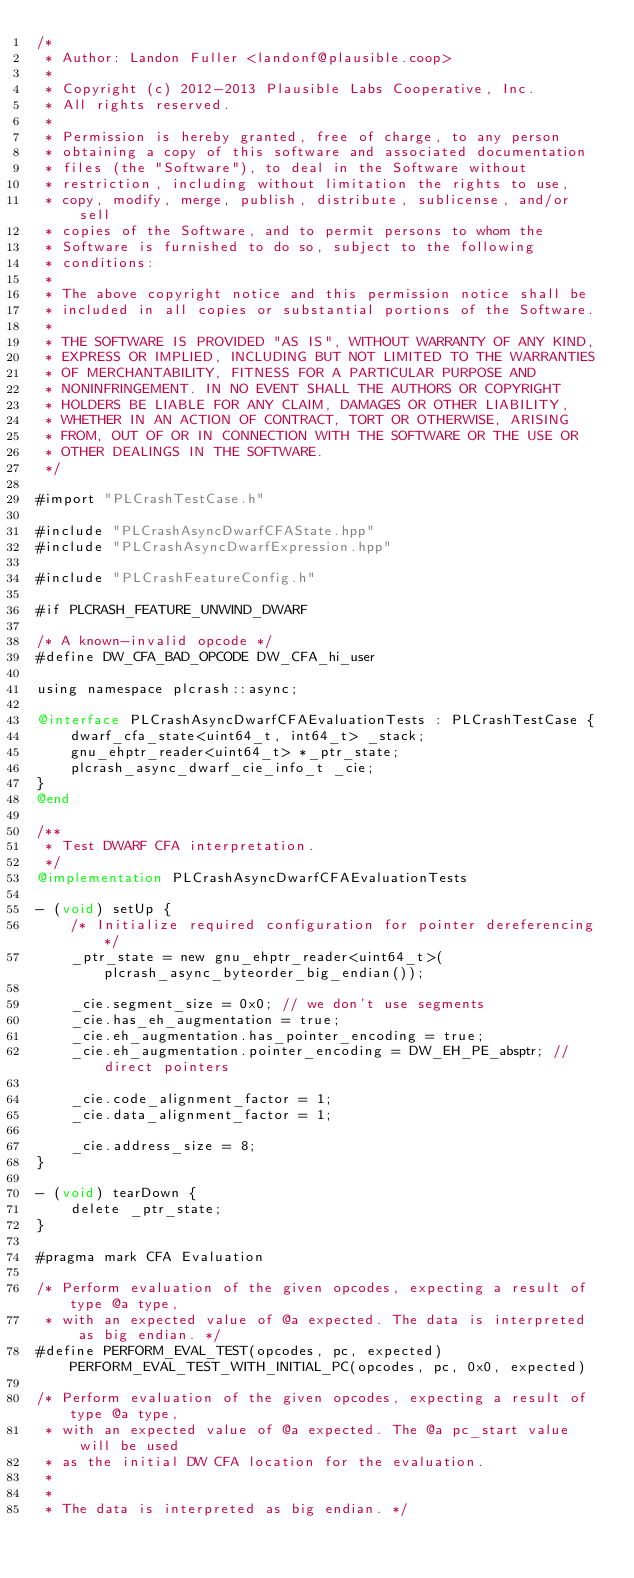<code> <loc_0><loc_0><loc_500><loc_500><_ObjectiveC_>/*
 * Author: Landon Fuller <landonf@plausible.coop>
 *
 * Copyright (c) 2012-2013 Plausible Labs Cooperative, Inc.
 * All rights reserved.
 *
 * Permission is hereby granted, free of charge, to any person
 * obtaining a copy of this software and associated documentation
 * files (the "Software"), to deal in the Software without
 * restriction, including without limitation the rights to use,
 * copy, modify, merge, publish, distribute, sublicense, and/or sell
 * copies of the Software, and to permit persons to whom the
 * Software is furnished to do so, subject to the following
 * conditions:
 *
 * The above copyright notice and this permission notice shall be
 * included in all copies or substantial portions of the Software.
 *
 * THE SOFTWARE IS PROVIDED "AS IS", WITHOUT WARRANTY OF ANY KIND,
 * EXPRESS OR IMPLIED, INCLUDING BUT NOT LIMITED TO THE WARRANTIES
 * OF MERCHANTABILITY, FITNESS FOR A PARTICULAR PURPOSE AND
 * NONINFRINGEMENT. IN NO EVENT SHALL THE AUTHORS OR COPYRIGHT
 * HOLDERS BE LIABLE FOR ANY CLAIM, DAMAGES OR OTHER LIABILITY,
 * WHETHER IN AN ACTION OF CONTRACT, TORT OR OTHERWISE, ARISING
 * FROM, OUT OF OR IN CONNECTION WITH THE SOFTWARE OR THE USE OR
 * OTHER DEALINGS IN THE SOFTWARE.
 */

#import "PLCrashTestCase.h"

#include "PLCrashAsyncDwarfCFAState.hpp"
#include "PLCrashAsyncDwarfExpression.hpp"

#include "PLCrashFeatureConfig.h"

#if PLCRASH_FEATURE_UNWIND_DWARF

/* A known-invalid opcode */
#define DW_CFA_BAD_OPCODE DW_CFA_hi_user

using namespace plcrash::async;

@interface PLCrashAsyncDwarfCFAEvaluationTests : PLCrashTestCase {
    dwarf_cfa_state<uint64_t, int64_t> _stack;
    gnu_ehptr_reader<uint64_t> *_ptr_state;
    plcrash_async_dwarf_cie_info_t _cie;
}
@end

/**
 * Test DWARF CFA interpretation.
 */
@implementation PLCrashAsyncDwarfCFAEvaluationTests

- (void) setUp {
    /* Initialize required configuration for pointer dereferencing */
    _ptr_state = new gnu_ehptr_reader<uint64_t>(plcrash_async_byteorder_big_endian());

    _cie.segment_size = 0x0; // we don't use segments
    _cie.has_eh_augmentation = true;
    _cie.eh_augmentation.has_pointer_encoding = true;
    _cie.eh_augmentation.pointer_encoding = DW_EH_PE_absptr; // direct pointers
    
    _cie.code_alignment_factor = 1;
    _cie.data_alignment_factor = 1;
    
    _cie.address_size = 8;
}

- (void) tearDown {
    delete _ptr_state;
}

#pragma mark CFA Evaluation

/* Perform evaluation of the given opcodes, expecting a result of type @a type,
 * with an expected value of @a expected. The data is interpreted as big endian. */
#define PERFORM_EVAL_TEST(opcodes, pc, expected) PERFORM_EVAL_TEST_WITH_INITIAL_PC(opcodes, pc, 0x0, expected)

/* Perform evaluation of the given opcodes, expecting a result of type @a type,
 * with an expected value of @a expected. The @a pc_start value will be used
 * as the initial DW CFA location for the evaluation.
 *
 *
 * The data is interpreted as big endian. */</code> 